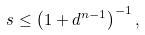Convert formula to latex. <formula><loc_0><loc_0><loc_500><loc_500>s \leq \left ( 1 + d ^ { n - 1 } \right ) ^ { - 1 } ,</formula> 